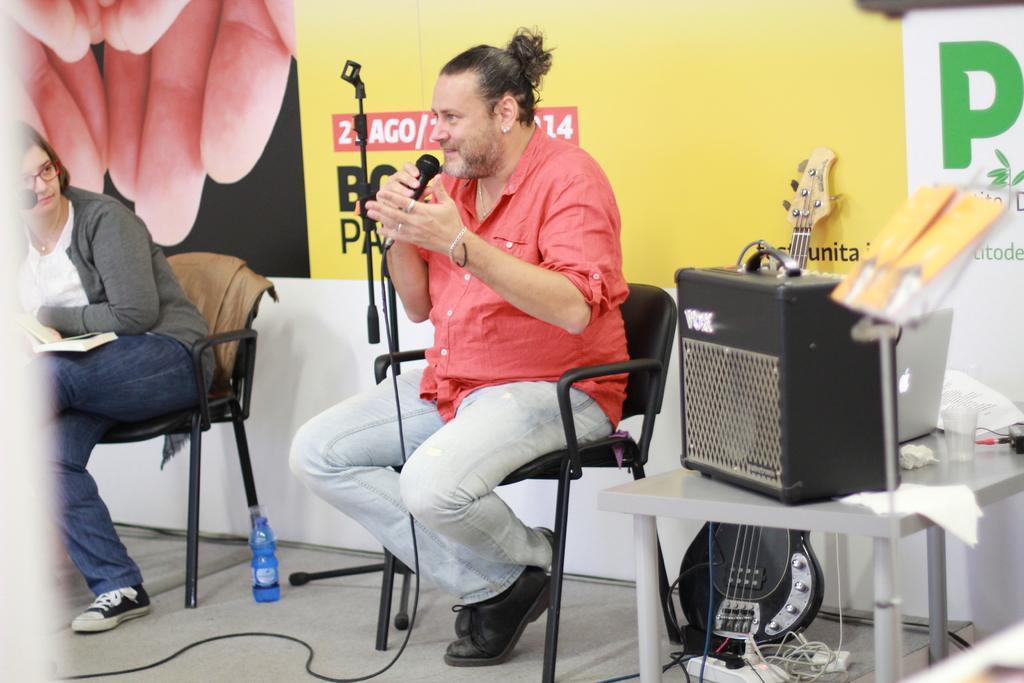Can you describe this image briefly? 2 people are sitting on the chairs. There is a bottle on the floor. The person at the center is wearing a pink shirt, pant and holding a microphone. There is a laptop, glass and other objects on a table. There is a banner at the back. 